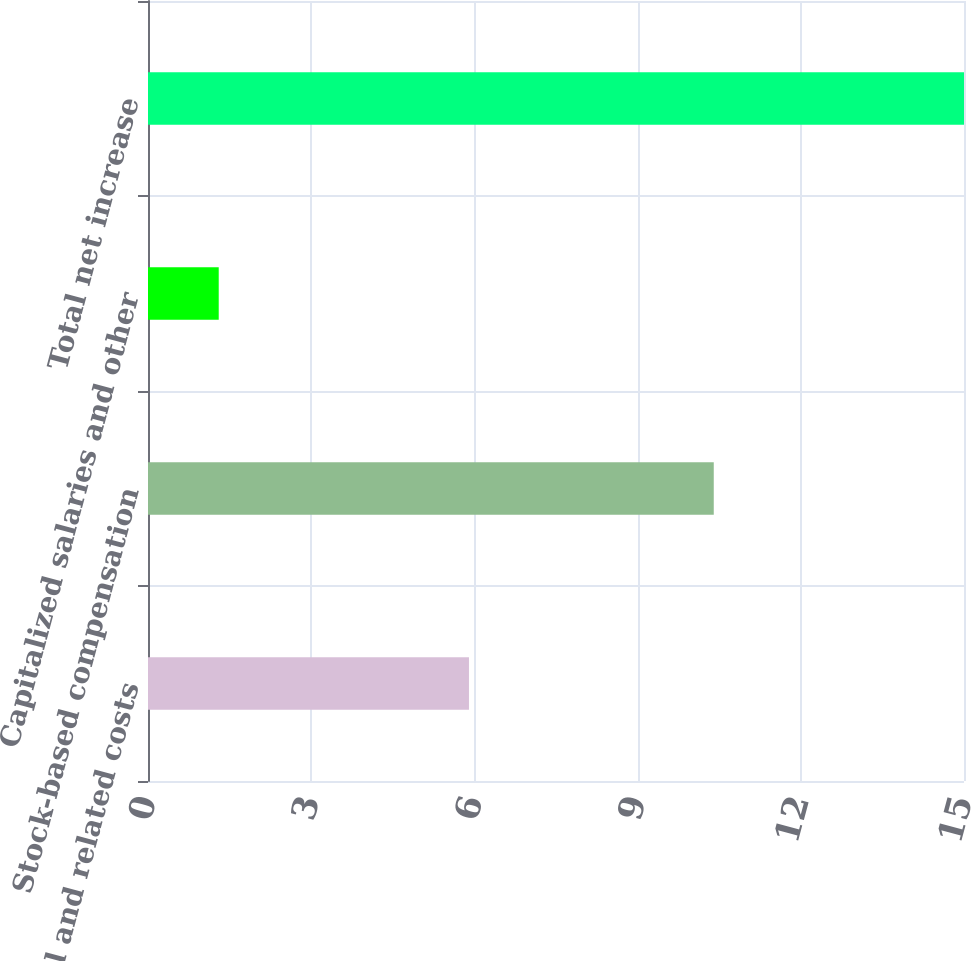Convert chart. <chart><loc_0><loc_0><loc_500><loc_500><bar_chart><fcel>Payroll and related costs<fcel>Stock-based compensation<fcel>Capitalized salaries and other<fcel>Total net increase<nl><fcel>5.9<fcel>10.4<fcel>1.3<fcel>15<nl></chart> 